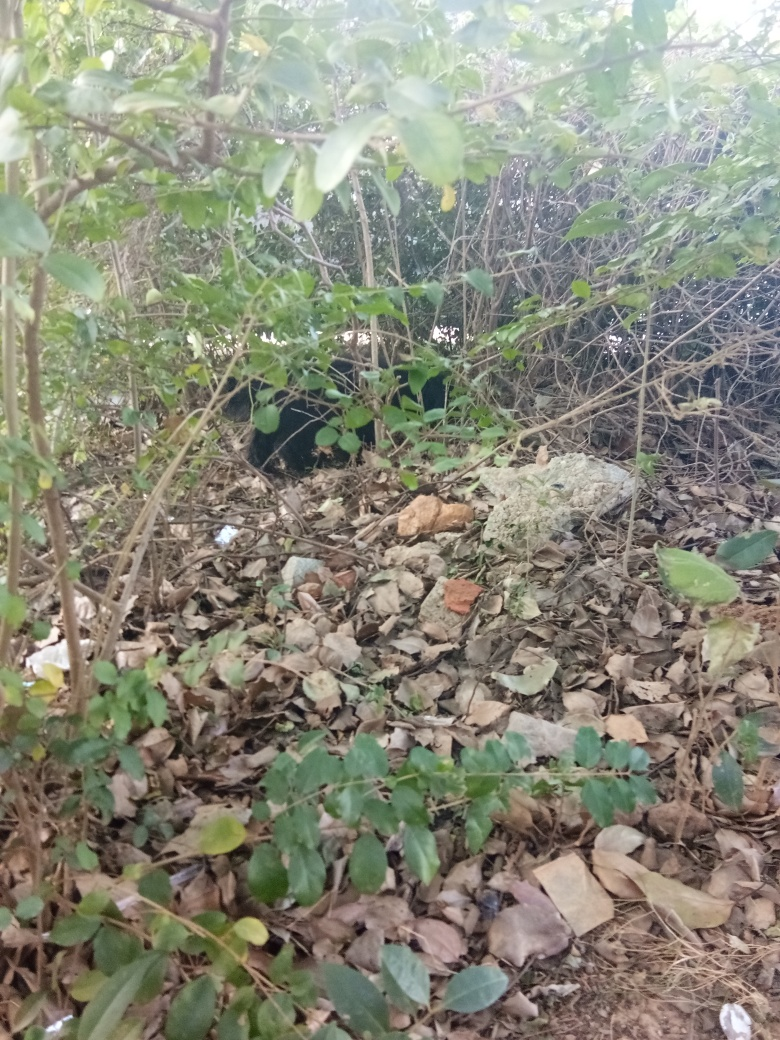What time of day does this photo seem to be taken? The photo appears to be taken during daytime, but the exact time is difficult to determine due to the lack of shadows and direct sunlight seen in the image. It might be on a cloudy day or in a shaded area. 